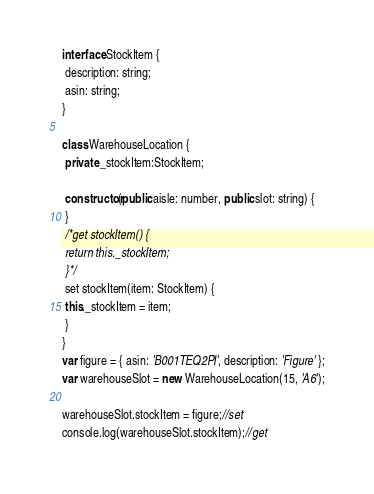Convert code to text. <code><loc_0><loc_0><loc_500><loc_500><_TypeScript_>interface StockItem {
 description: string;
 asin: string;
}

class WarehouseLocation {
 private _stockItem:StockItem;

 constructor(public aisle: number, public slot: string) {
 }
 /*get stockItem() {
 return this._stockItem;
 }*/
 set stockItem(item: StockItem) {
 this._stockItem = item;
 }
}
var figure = { asin: 'B001TEQ2PI', description: 'Figure' };
var warehouseSlot = new WarehouseLocation(15, 'A6');

warehouseSlot.stockItem = figure;//set
console.log(warehouseSlot.stockItem);//get</code> 